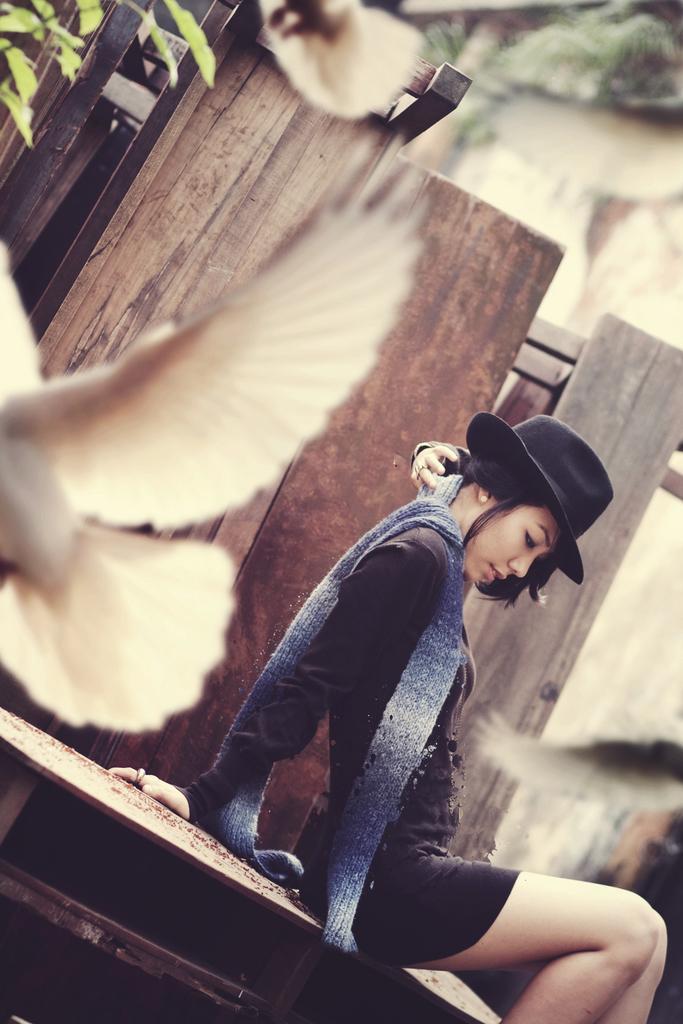Describe this image in one or two sentences. In this picture there is a girl wearing black color t- shirt with black cap and blue muffler sitting on the bench. Behind there is a wooden wall panels and white pigeons flying in the air. Behind there is a white wall and some plants. 